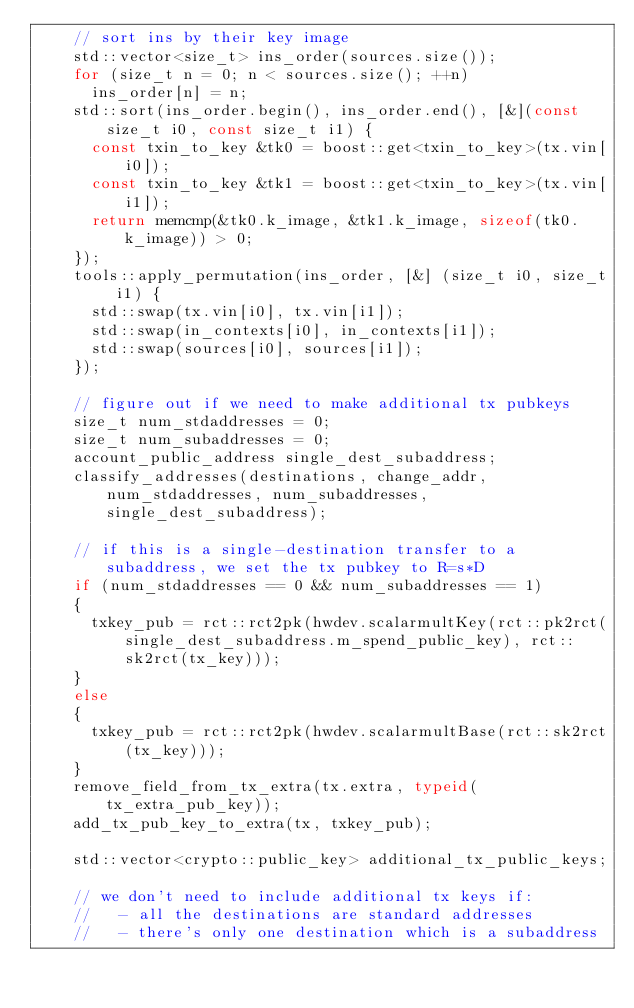<code> <loc_0><loc_0><loc_500><loc_500><_C++_>    // sort ins by their key image
    std::vector<size_t> ins_order(sources.size());
    for (size_t n = 0; n < sources.size(); ++n)
      ins_order[n] = n;
    std::sort(ins_order.begin(), ins_order.end(), [&](const size_t i0, const size_t i1) {
      const txin_to_key &tk0 = boost::get<txin_to_key>(tx.vin[i0]);
      const txin_to_key &tk1 = boost::get<txin_to_key>(tx.vin[i1]);
      return memcmp(&tk0.k_image, &tk1.k_image, sizeof(tk0.k_image)) > 0;
    });
    tools::apply_permutation(ins_order, [&] (size_t i0, size_t i1) {
      std::swap(tx.vin[i0], tx.vin[i1]);
      std::swap(in_contexts[i0], in_contexts[i1]);
      std::swap(sources[i0], sources[i1]);
    });

    // figure out if we need to make additional tx pubkeys
    size_t num_stdaddresses = 0;
    size_t num_subaddresses = 0;
    account_public_address single_dest_subaddress;
    classify_addresses(destinations, change_addr, num_stdaddresses, num_subaddresses, single_dest_subaddress);

    // if this is a single-destination transfer to a subaddress, we set the tx pubkey to R=s*D
    if (num_stdaddresses == 0 && num_subaddresses == 1)
    {
      txkey_pub = rct::rct2pk(hwdev.scalarmultKey(rct::pk2rct(single_dest_subaddress.m_spend_public_key), rct::sk2rct(tx_key)));
    }
    else
    {
      txkey_pub = rct::rct2pk(hwdev.scalarmultBase(rct::sk2rct(tx_key)));
    }
    remove_field_from_tx_extra(tx.extra, typeid(tx_extra_pub_key));
    add_tx_pub_key_to_extra(tx, txkey_pub);

    std::vector<crypto::public_key> additional_tx_public_keys;

    // we don't need to include additional tx keys if:
    //   - all the destinations are standard addresses
    //   - there's only one destination which is a subaddress</code> 